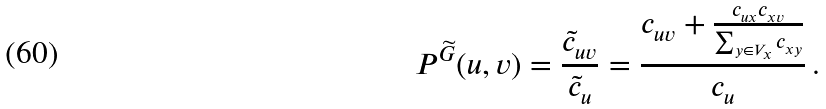Convert formula to latex. <formula><loc_0><loc_0><loc_500><loc_500>P ^ { \widetilde { G } } ( u , v ) = \frac { \tilde { c } _ { u v } } { \tilde { c } _ { u } } = \frac { c _ { u v } + \frac { c _ { u x } c _ { x v } } { \sum _ { y \in V _ { x } } c _ { x y } } } { c _ { u } } \, .</formula> 